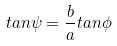Convert formula to latex. <formula><loc_0><loc_0><loc_500><loc_500>t a n \psi = \frac { b } { a } t a n \phi</formula> 